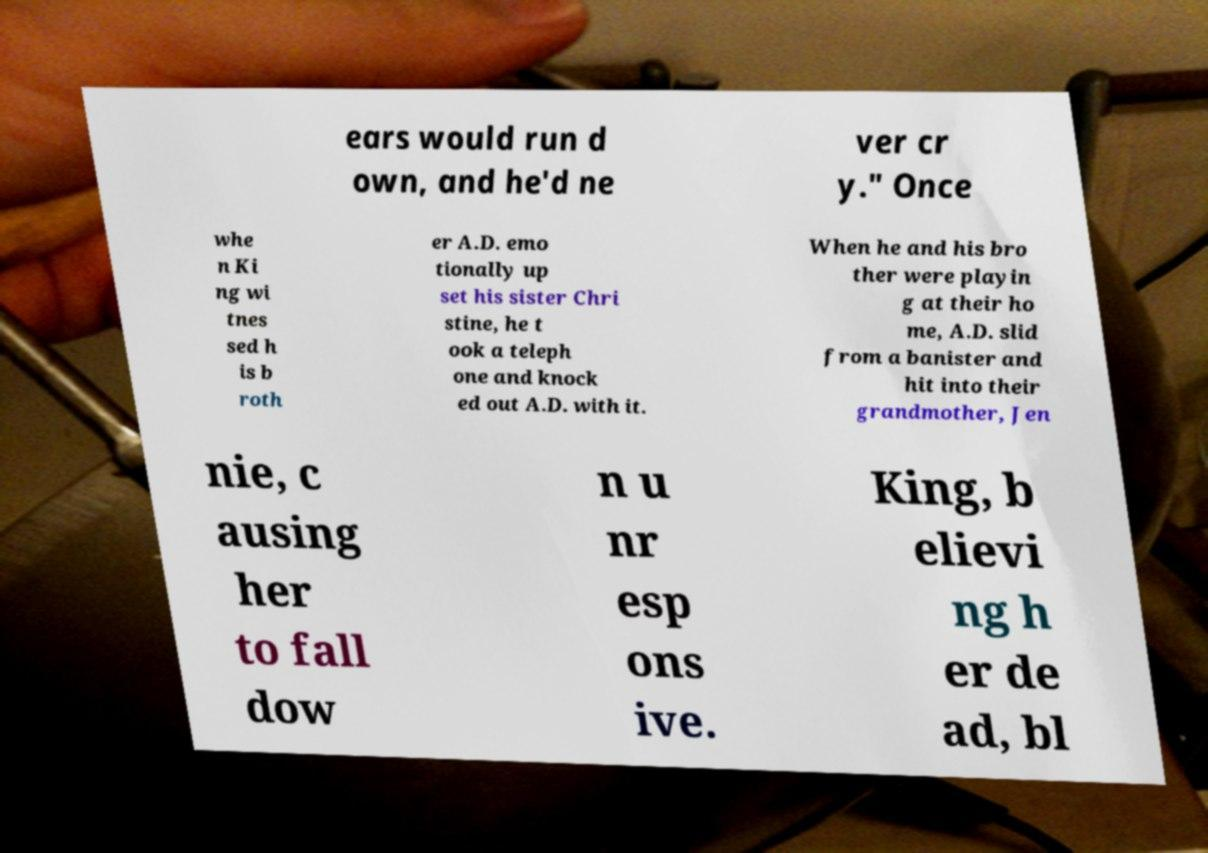I need the written content from this picture converted into text. Can you do that? ears would run d own, and he'd ne ver cr y." Once whe n Ki ng wi tnes sed h is b roth er A.D. emo tionally up set his sister Chri stine, he t ook a teleph one and knock ed out A.D. with it. When he and his bro ther were playin g at their ho me, A.D. slid from a banister and hit into their grandmother, Jen nie, c ausing her to fall dow n u nr esp ons ive. King, b elievi ng h er de ad, bl 